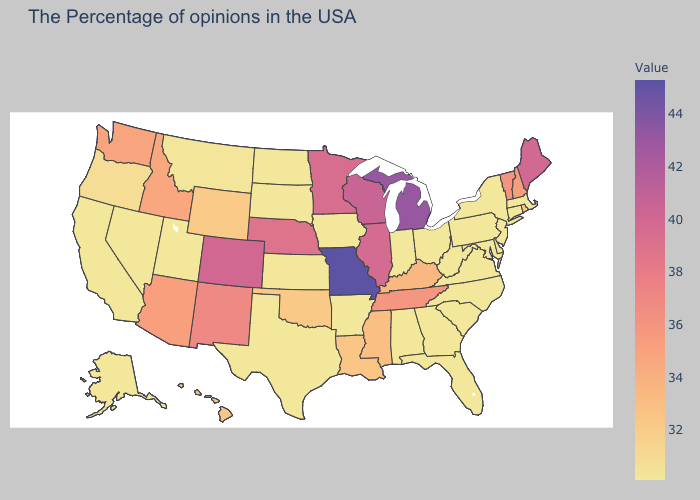Does Montana have the highest value in the West?
Concise answer only. No. Does the map have missing data?
Be succinct. No. Does California have the highest value in the West?
Write a very short answer. No. Among the states that border Michigan , which have the lowest value?
Quick response, please. Ohio, Indiana. Does West Virginia have the lowest value in the USA?
Short answer required. Yes. 